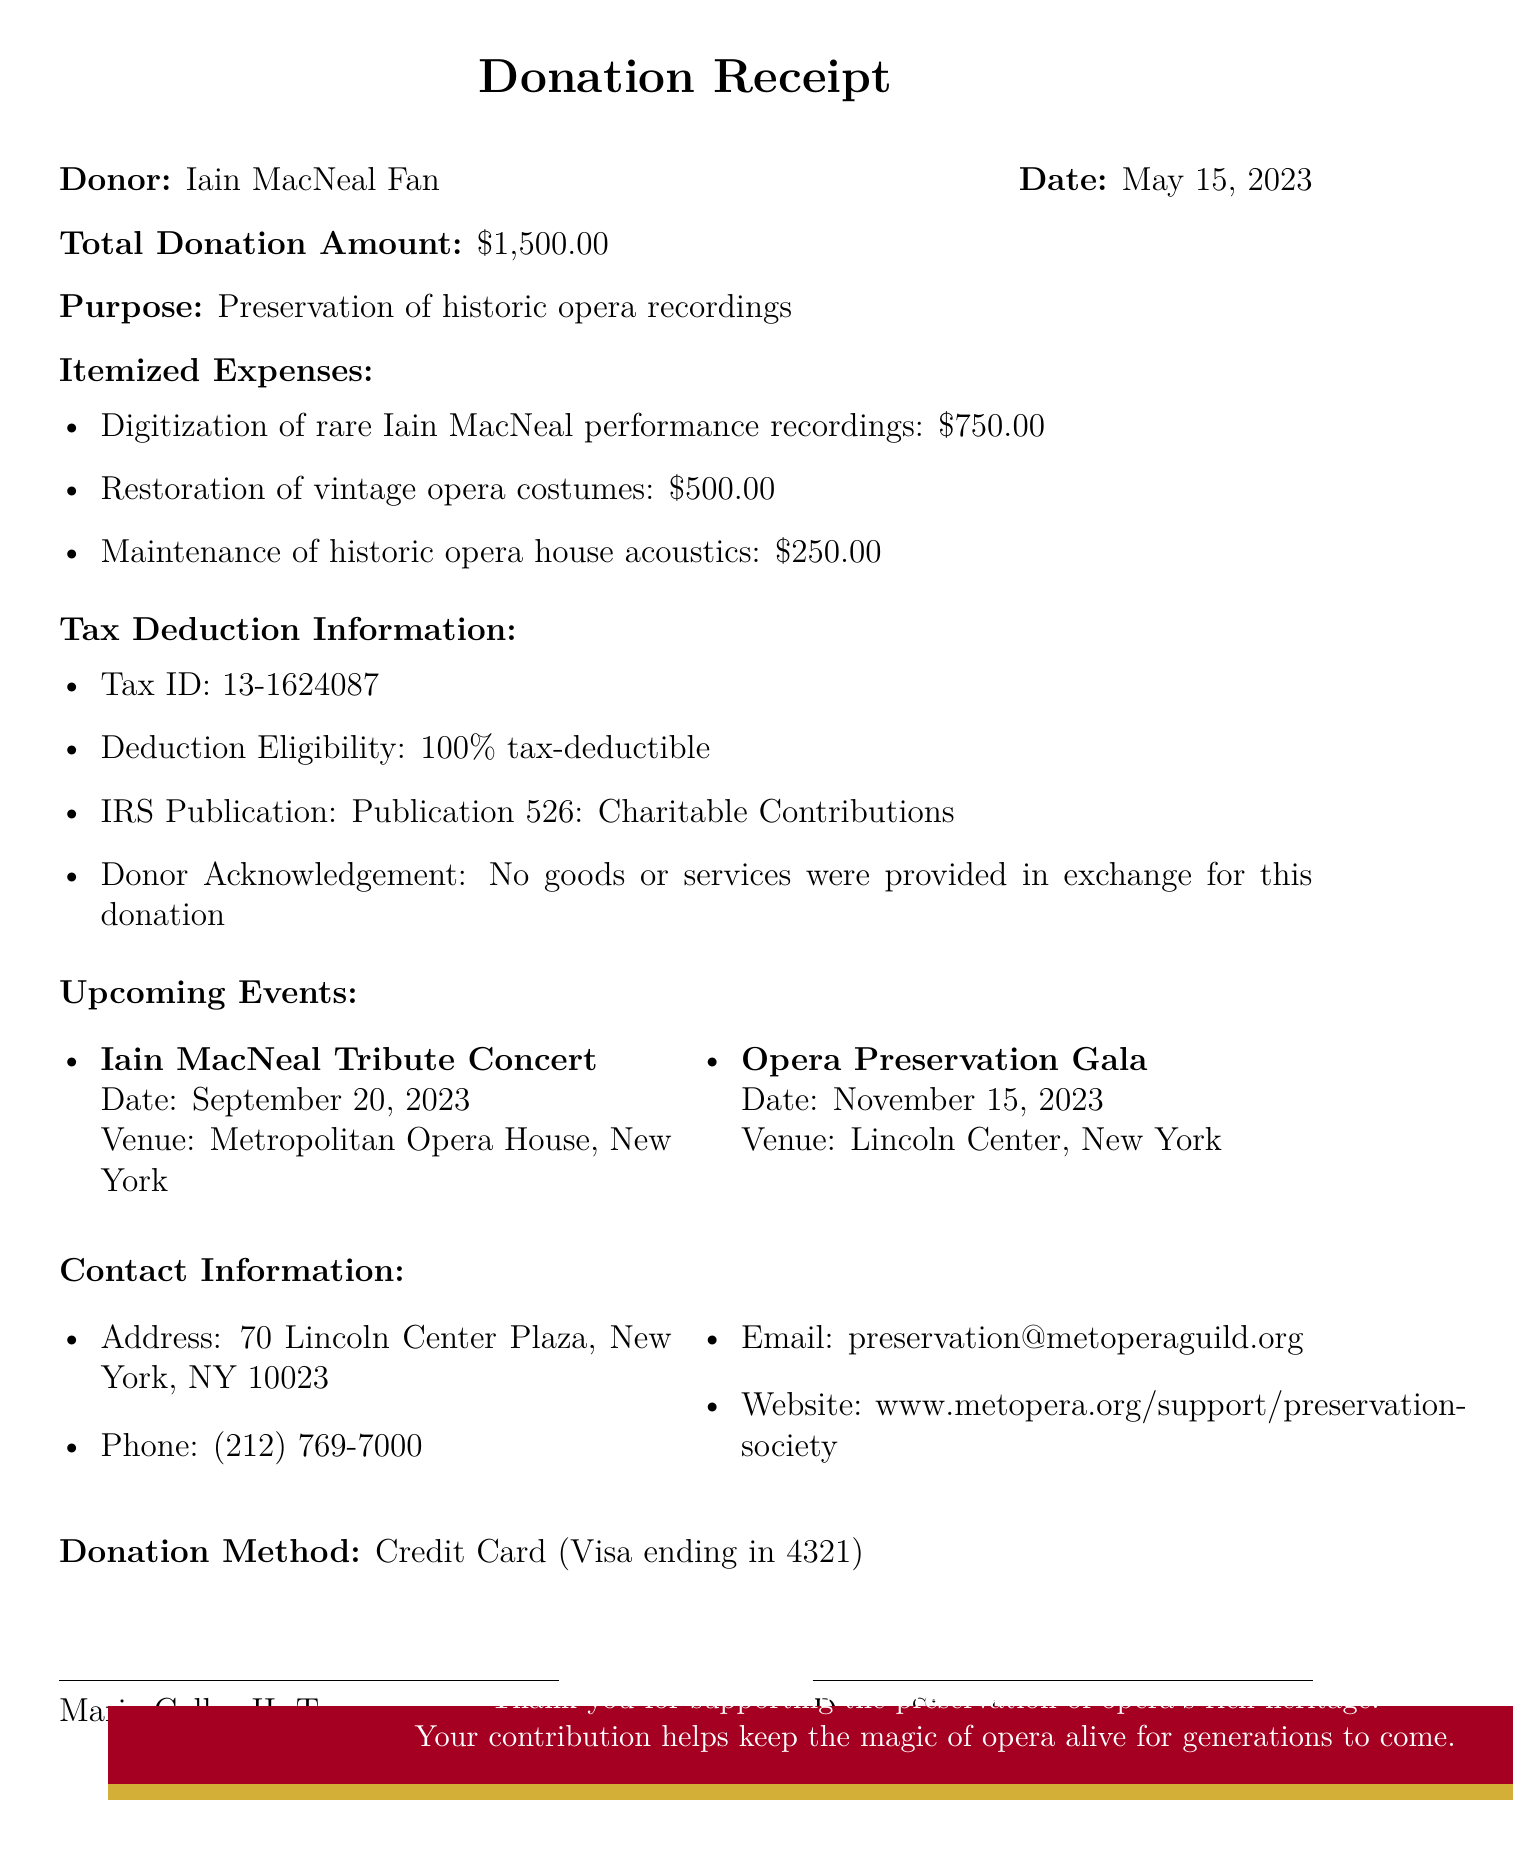What is the name of the organization? The name of the organization is mentioned at the top of the document.
Answer: Metropolitan Opera Guild Preservation Society What is the donor's name? The document specifies the name of the donor in the header section.
Answer: Iain MacNeal Fan What was the donation amount? The total donation amount is clearly stated in the document.
Answer: $1,500.00 What is the purpose of the donation? The purpose of the donation is described in one of the sections of the document.
Answer: Preservation of historic opera recordings How much was allocated for the digitization of recordings? The specific amount for digitization is outlined in the itemized expenses.
Answer: $750.00 Which IRS publication is referenced for tax deductions? The specific IRS publication referenced in the tax deduction information is indicated in the document.
Answer: Publication 526: Charitable Contributions Were any goods or services provided for the donation? The document states the acknowledgment regarding the exchange for goods or services.
Answer: No When is the Iain MacNeal Tribute Concert scheduled? The date of the upcoming event is listed in the events section of the document.
Answer: September 20, 2023 What is the donation method mentioned in the document? The donation method is detailed toward the end of the document.
Answer: Credit Card (Visa ending in 4321) 